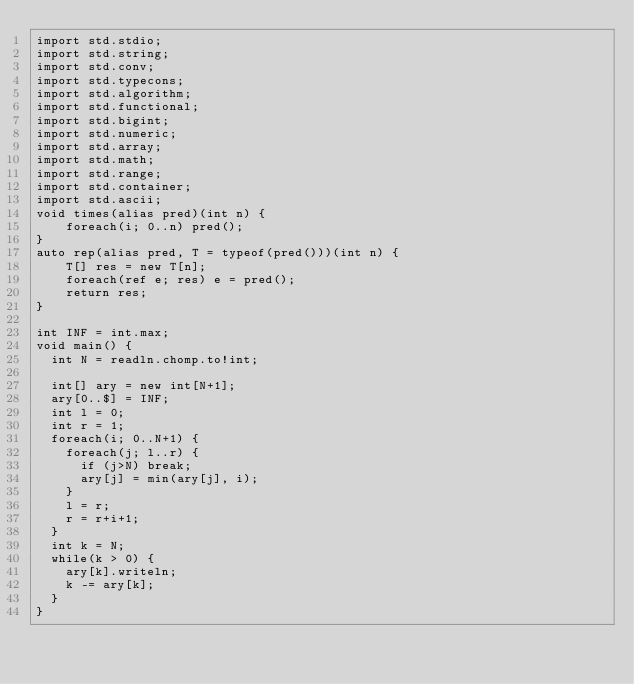Convert code to text. <code><loc_0><loc_0><loc_500><loc_500><_D_>import std.stdio;
import std.string;
import std.conv;
import std.typecons;
import std.algorithm;
import std.functional;
import std.bigint;
import std.numeric;
import std.array;
import std.math;
import std.range;
import std.container;
import std.ascii;
void times(alias pred)(int n) {
    foreach(i; 0..n) pred();
}
auto rep(alias pred, T = typeof(pred()))(int n) {
    T[] res = new T[n];
    foreach(ref e; res) e = pred();
    return res;
}

int INF = int.max;
void main() {
  int N = readln.chomp.to!int;

  int[] ary = new int[N+1];
  ary[0..$] = INF;
  int l = 0;
  int r = 1;
  foreach(i; 0..N+1) {
    foreach(j; l..r) {
      if (j>N) break;
      ary[j] = min(ary[j], i);
    }
    l = r;
    r = r+i+1;
  }
  int k = N;
  while(k > 0) {
    ary[k].writeln;
    k -= ary[k];
  }
}
</code> 